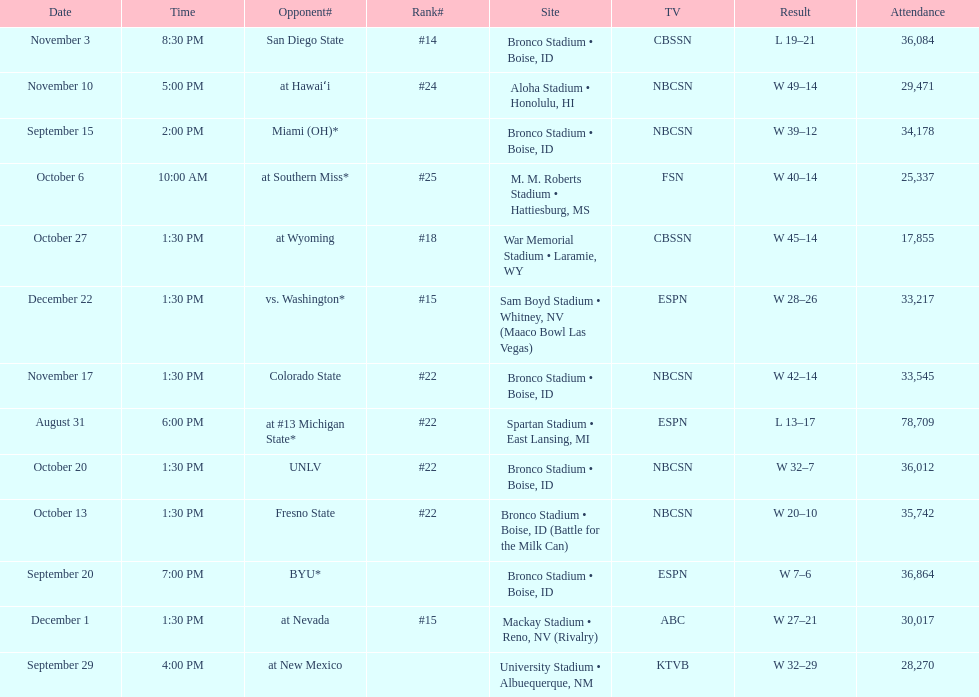Which team has the highest rank among those listed? San Diego State. 